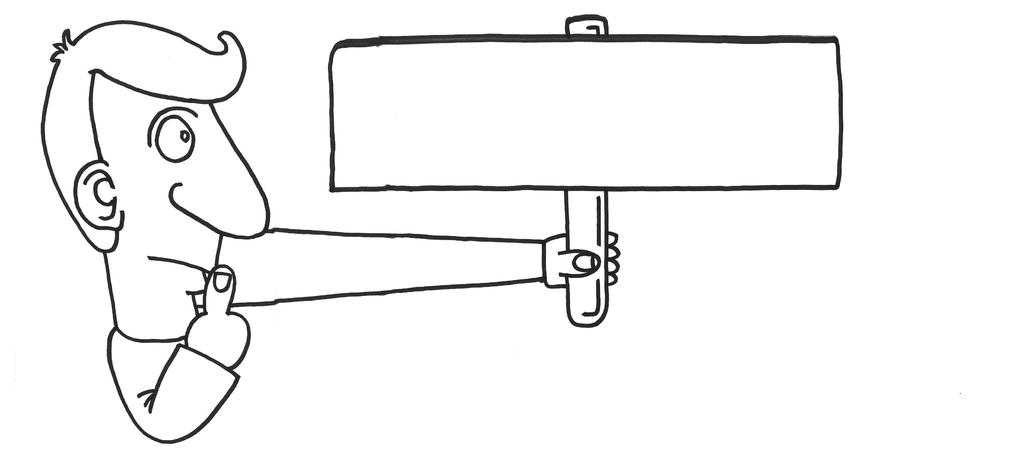What is the main subject of the image? The main subject of the image is a sketch of a cartoon. What is the cartoon holding in the image? The cartoon is holding an object in the image. What type of sink is visible in the image? There is no sink present in the image; it features a sketch of a cartoon holding an object. What nation is represented by the cartoon in the image? The image does not depict a specific nation or nationality; it is a sketch of a cartoon holding an object. 